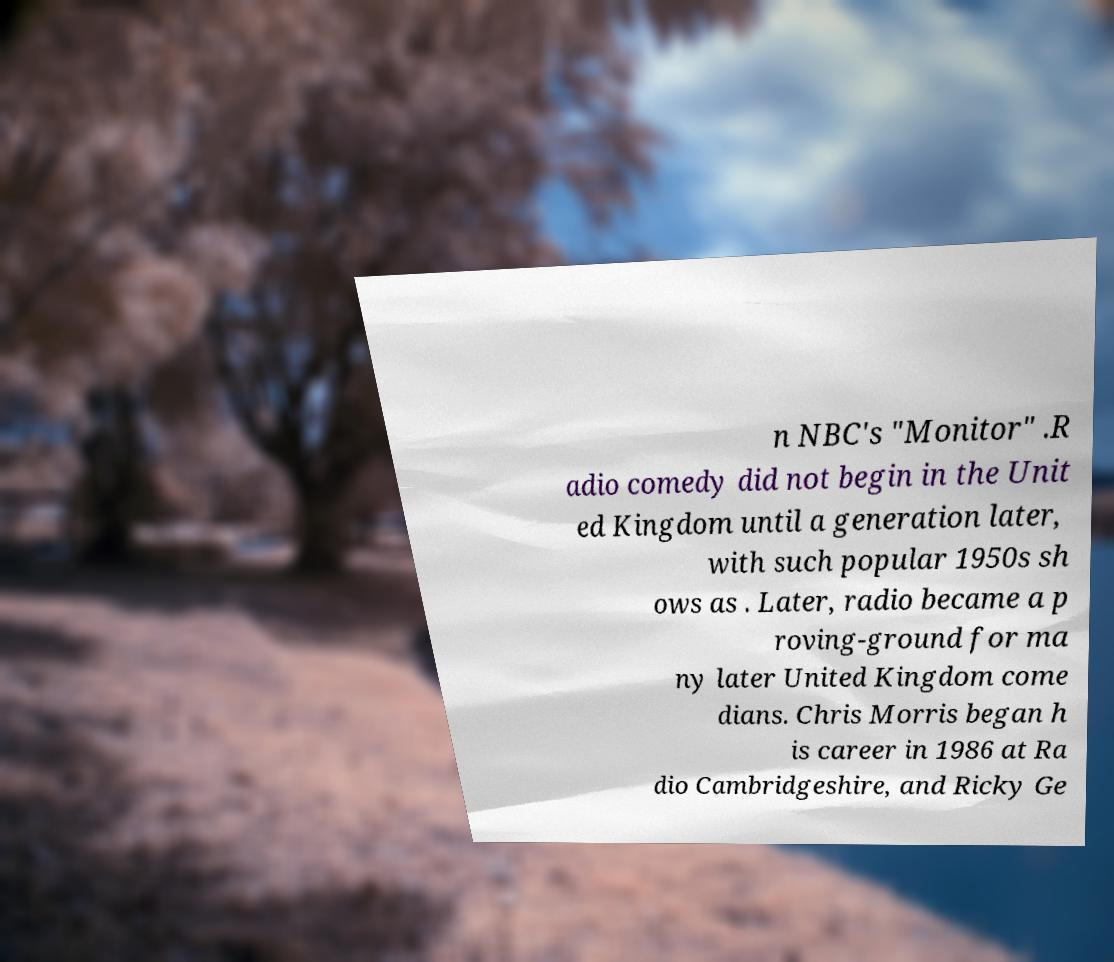For documentation purposes, I need the text within this image transcribed. Could you provide that? n NBC's "Monitor" .R adio comedy did not begin in the Unit ed Kingdom until a generation later, with such popular 1950s sh ows as . Later, radio became a p roving-ground for ma ny later United Kingdom come dians. Chris Morris began h is career in 1986 at Ra dio Cambridgeshire, and Ricky Ge 